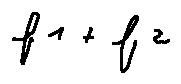Convert formula to latex. <formula><loc_0><loc_0><loc_500><loc_500>f _ { 1 } + f _ { 2 }</formula> 